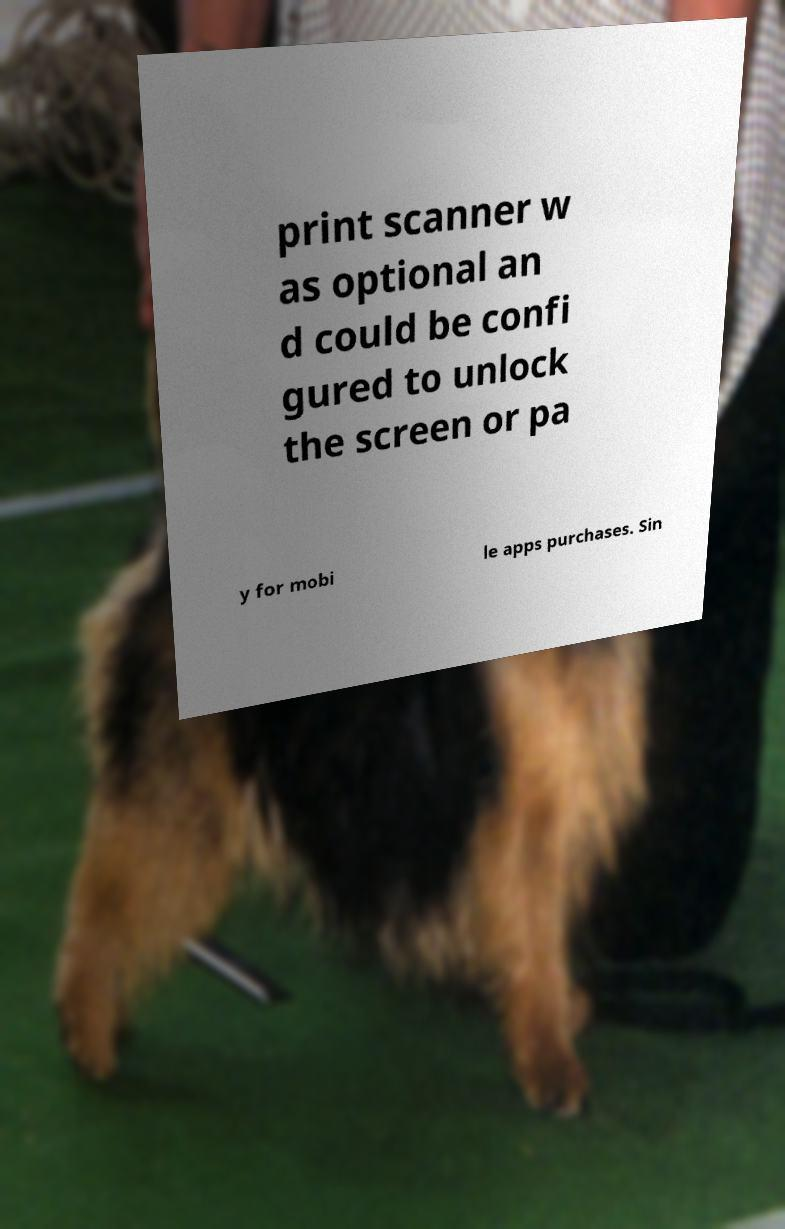Can you accurately transcribe the text from the provided image for me? print scanner w as optional an d could be confi gured to unlock the screen or pa y for mobi le apps purchases. Sin 